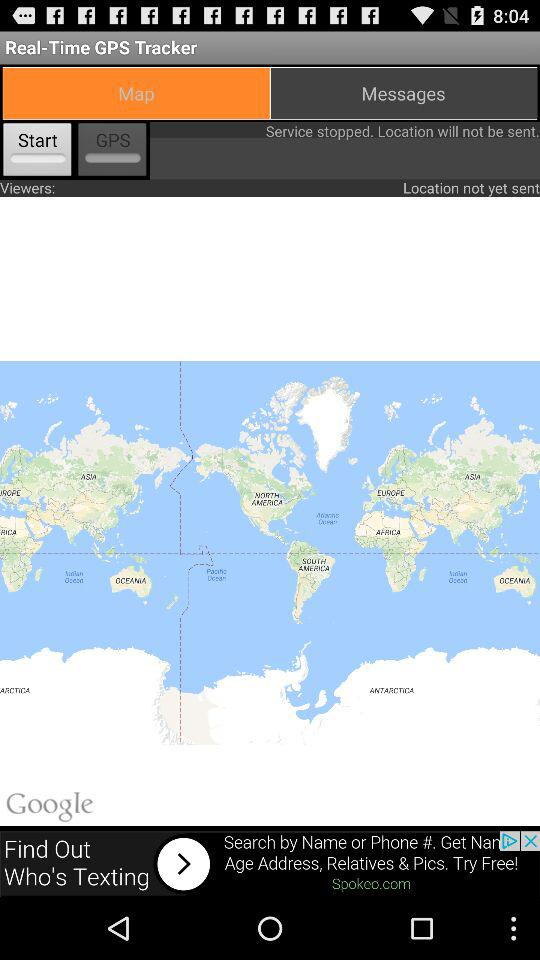Which tab is selected? The selected tab is "Map". 